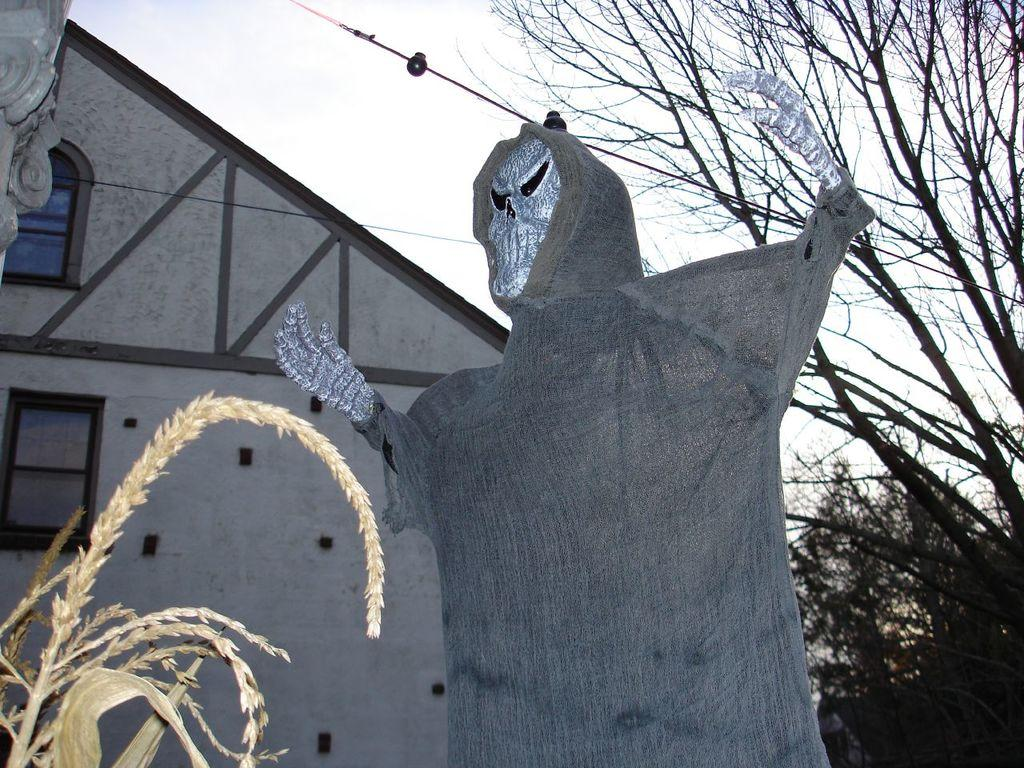What type of statue is in the image? There is a ghost statue in the image. What other objects or features can be seen in the image? There are trees, wires, a house with windows, plants on the bottom left, and the sky is visible. Can you describe the house in the image? The house has windows and is surrounded by trees and wires. Where are the plants located in the image? The plants are on the bottom left of the image. What type of mine can be seen in the image? There is no mine present in the image. How many rifles are visible in the image? There are no rifles present in the image. 